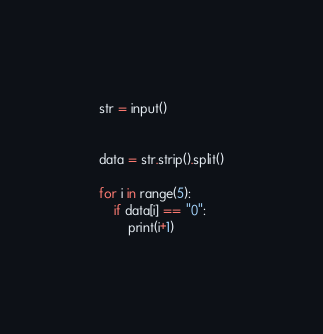<code> <loc_0><loc_0><loc_500><loc_500><_Python_>str = input()


data = str.strip().split()

for i in range(5):
    if data[i] == "0":
        print(i+1)</code> 